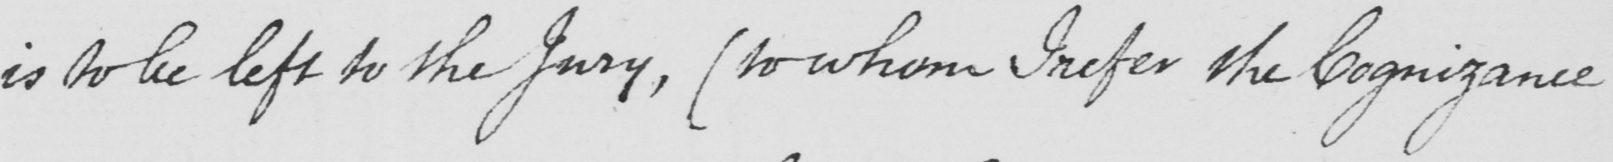Transcribe the text shown in this historical manuscript line. is to be left to the Jury , ( to whom I refer the Cognizance 